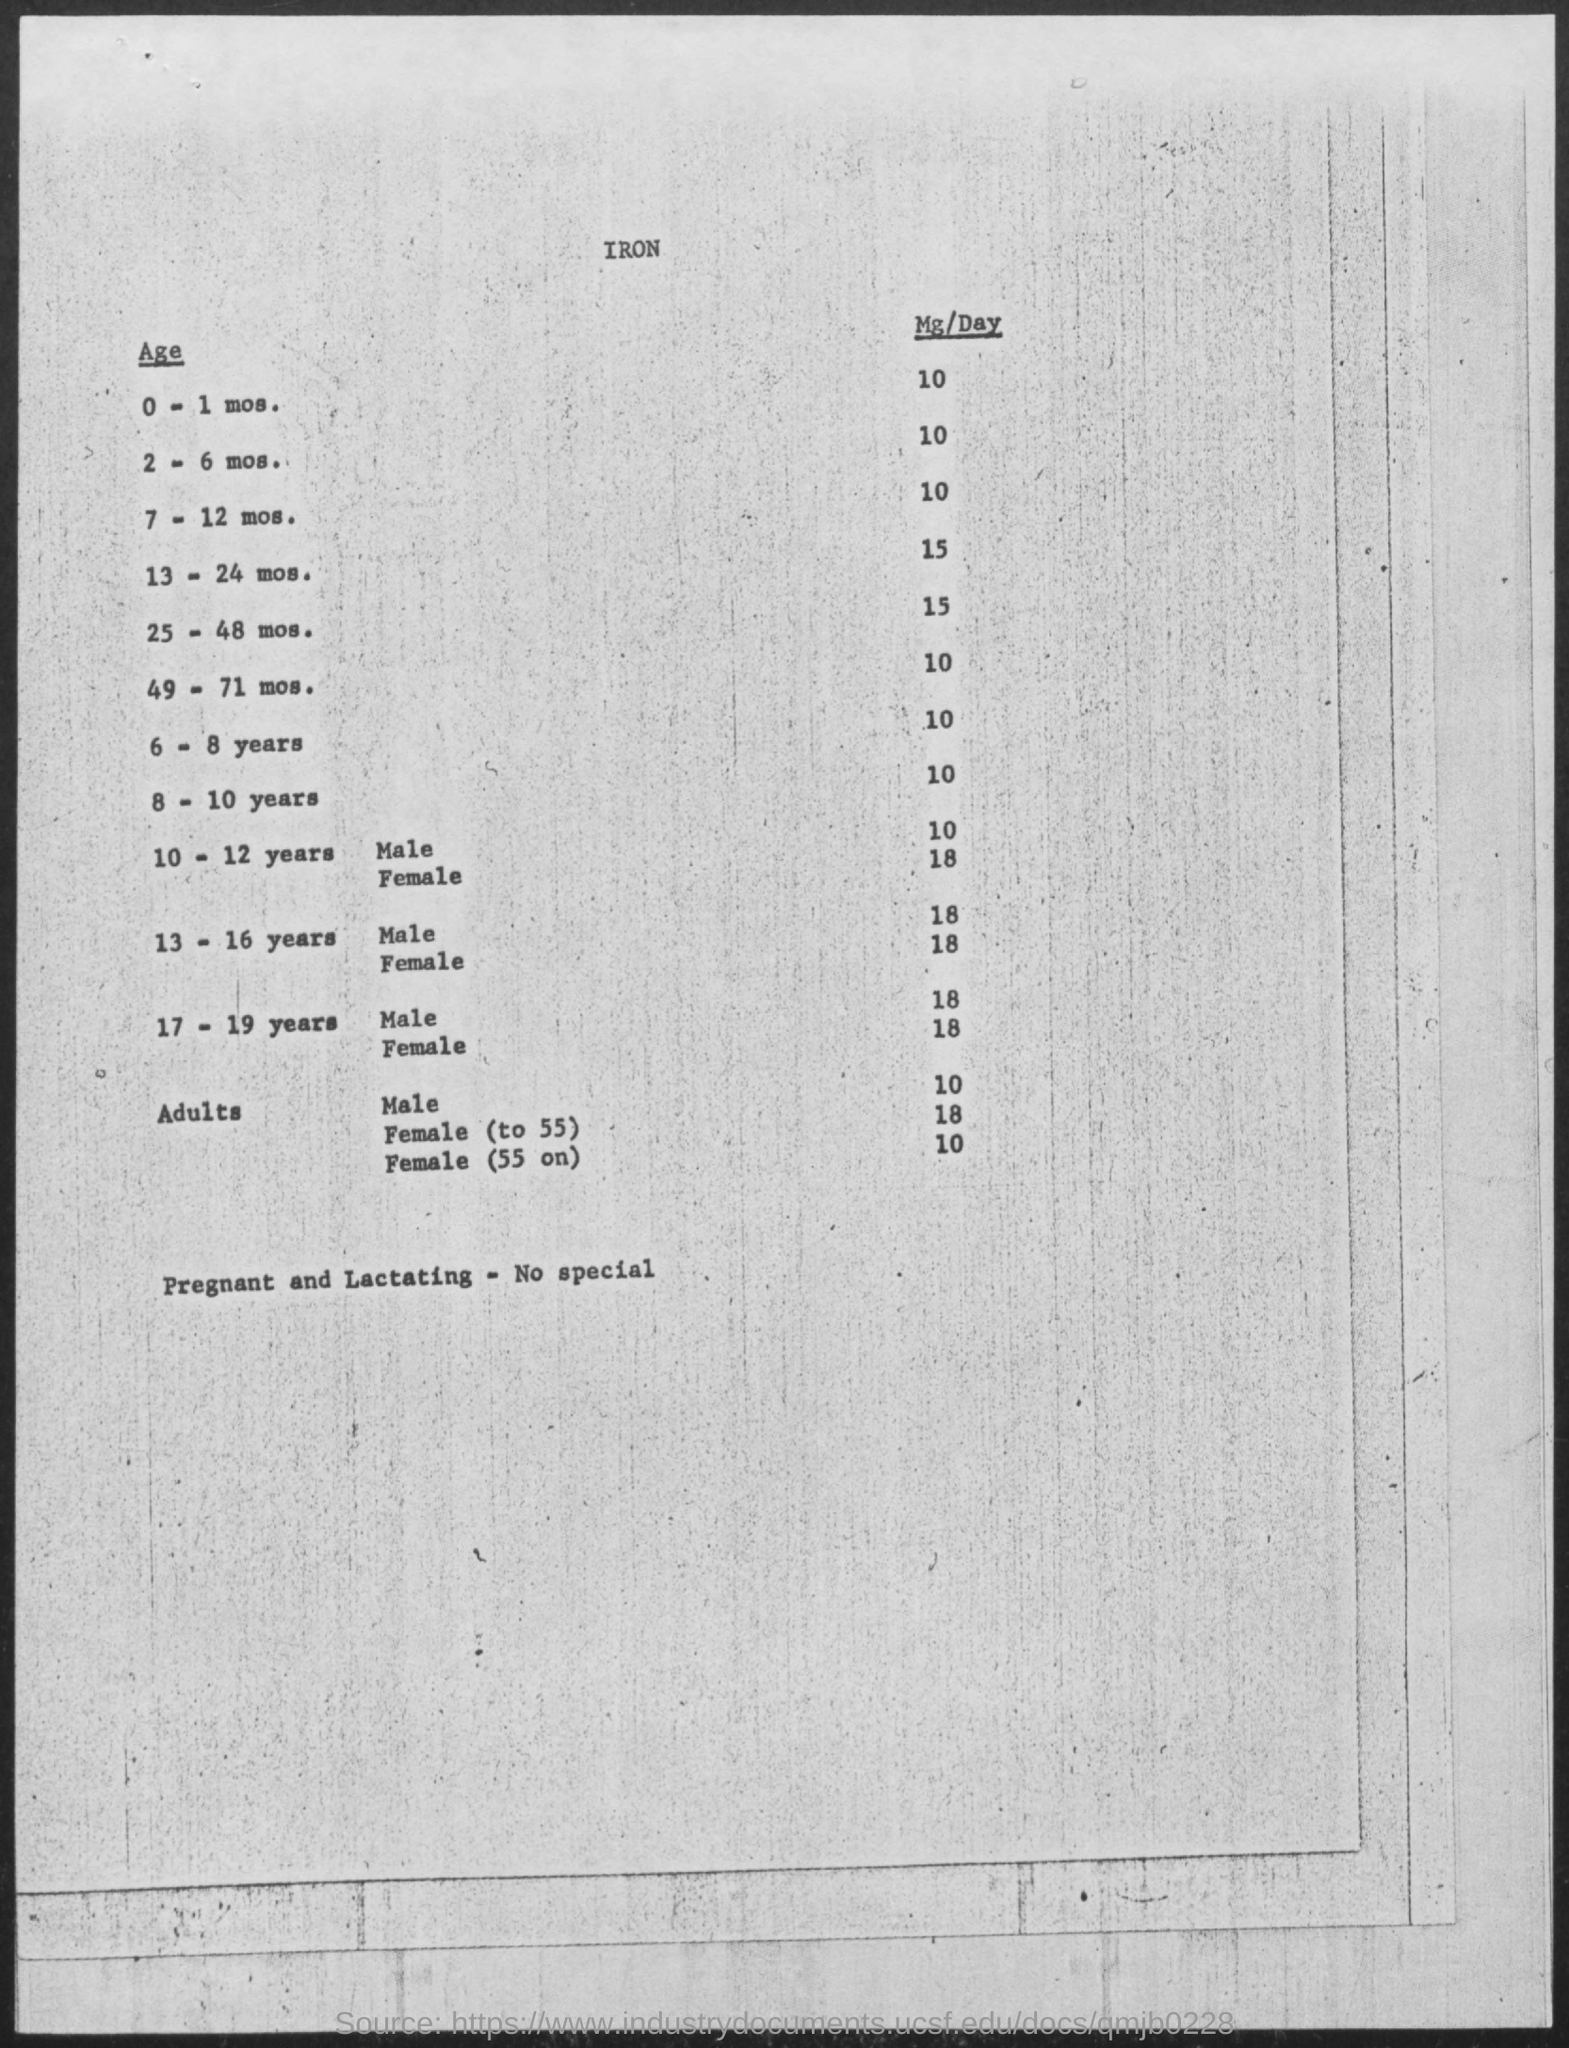How much Mg/Day iron for 0-1 mos.?
Ensure brevity in your answer.  10. How much Mg/Day iron for 2-6 mos.?
Give a very brief answer. 10. How much Mg/Day iron for 7-12 mos.?
Give a very brief answer. 10. How much Mg/Day iron for 13-24 mos.?
Your answer should be compact. 15. How much Mg/Day iron for 25-48 mos.?
Offer a very short reply. 15. How much Mg/Day iron for 49-71 mos.?
Your answer should be very brief. 10. How much Mg/Day iron for 6-8 years?
Make the answer very short. 10. How much Mg/Day iron for 8-10 years?
Your answer should be very brief. 10. How much Mg/Day iron for 10-12 years Male?
Give a very brief answer. 10. How much Mg/Day iron for 10-12 years FeMale?
Provide a short and direct response. 18. 